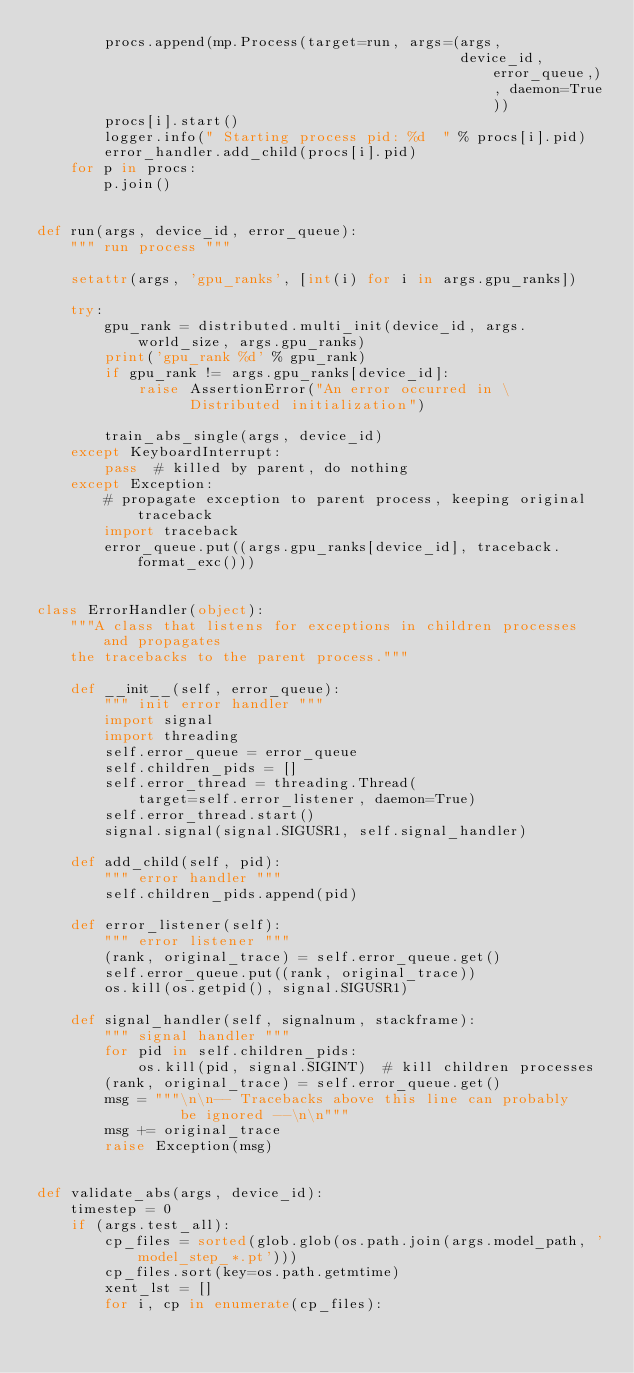<code> <loc_0><loc_0><loc_500><loc_500><_Python_>        procs.append(mp.Process(target=run, args=(args,
                                                  device_id, error_queue,), daemon=True))
        procs[i].start()
        logger.info(" Starting process pid: %d  " % procs[i].pid)
        error_handler.add_child(procs[i].pid)
    for p in procs:
        p.join()


def run(args, device_id, error_queue):
    """ run process """

    setattr(args, 'gpu_ranks', [int(i) for i in args.gpu_ranks])

    try:
        gpu_rank = distributed.multi_init(device_id, args.world_size, args.gpu_ranks)
        print('gpu_rank %d' % gpu_rank)
        if gpu_rank != args.gpu_ranks[device_id]:
            raise AssertionError("An error occurred in \
                  Distributed initialization")

        train_abs_single(args, device_id)
    except KeyboardInterrupt:
        pass  # killed by parent, do nothing
    except Exception:
        # propagate exception to parent process, keeping original traceback
        import traceback
        error_queue.put((args.gpu_ranks[device_id], traceback.format_exc()))


class ErrorHandler(object):
    """A class that listens for exceptions in children processes and propagates
    the tracebacks to the parent process."""

    def __init__(self, error_queue):
        """ init error handler """
        import signal
        import threading
        self.error_queue = error_queue
        self.children_pids = []
        self.error_thread = threading.Thread(
            target=self.error_listener, daemon=True)
        self.error_thread.start()
        signal.signal(signal.SIGUSR1, self.signal_handler)

    def add_child(self, pid):
        """ error handler """
        self.children_pids.append(pid)

    def error_listener(self):
        """ error listener """
        (rank, original_trace) = self.error_queue.get()
        self.error_queue.put((rank, original_trace))
        os.kill(os.getpid(), signal.SIGUSR1)

    def signal_handler(self, signalnum, stackframe):
        """ signal handler """
        for pid in self.children_pids:
            os.kill(pid, signal.SIGINT)  # kill children processes
        (rank, original_trace) = self.error_queue.get()
        msg = """\n\n-- Tracebacks above this line can probably
                 be ignored --\n\n"""
        msg += original_trace
        raise Exception(msg)


def validate_abs(args, device_id):
    timestep = 0
    if (args.test_all):
        cp_files = sorted(glob.glob(os.path.join(args.model_path, 'model_step_*.pt')))
        cp_files.sort(key=os.path.getmtime)
        xent_lst = []
        for i, cp in enumerate(cp_files):</code> 